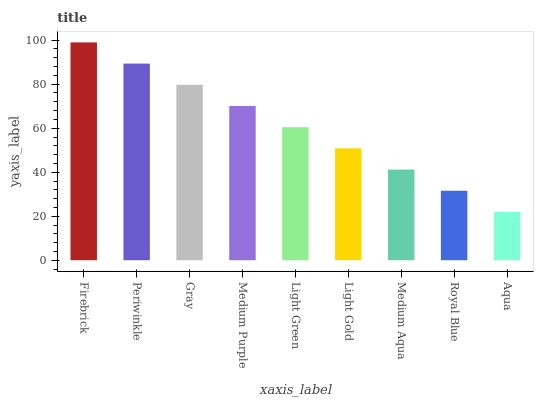Is Aqua the minimum?
Answer yes or no. Yes. Is Firebrick the maximum?
Answer yes or no. Yes. Is Periwinkle the minimum?
Answer yes or no. No. Is Periwinkle the maximum?
Answer yes or no. No. Is Firebrick greater than Periwinkle?
Answer yes or no. Yes. Is Periwinkle less than Firebrick?
Answer yes or no. Yes. Is Periwinkle greater than Firebrick?
Answer yes or no. No. Is Firebrick less than Periwinkle?
Answer yes or no. No. Is Light Green the high median?
Answer yes or no. Yes. Is Light Green the low median?
Answer yes or no. Yes. Is Royal Blue the high median?
Answer yes or no. No. Is Medium Purple the low median?
Answer yes or no. No. 